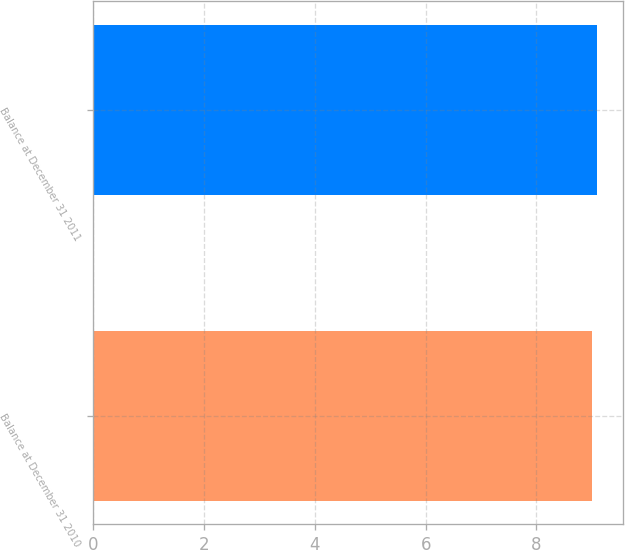<chart> <loc_0><loc_0><loc_500><loc_500><bar_chart><fcel>Balance at December 31 2010<fcel>Balance at December 31 2011<nl><fcel>9<fcel>9.1<nl></chart> 